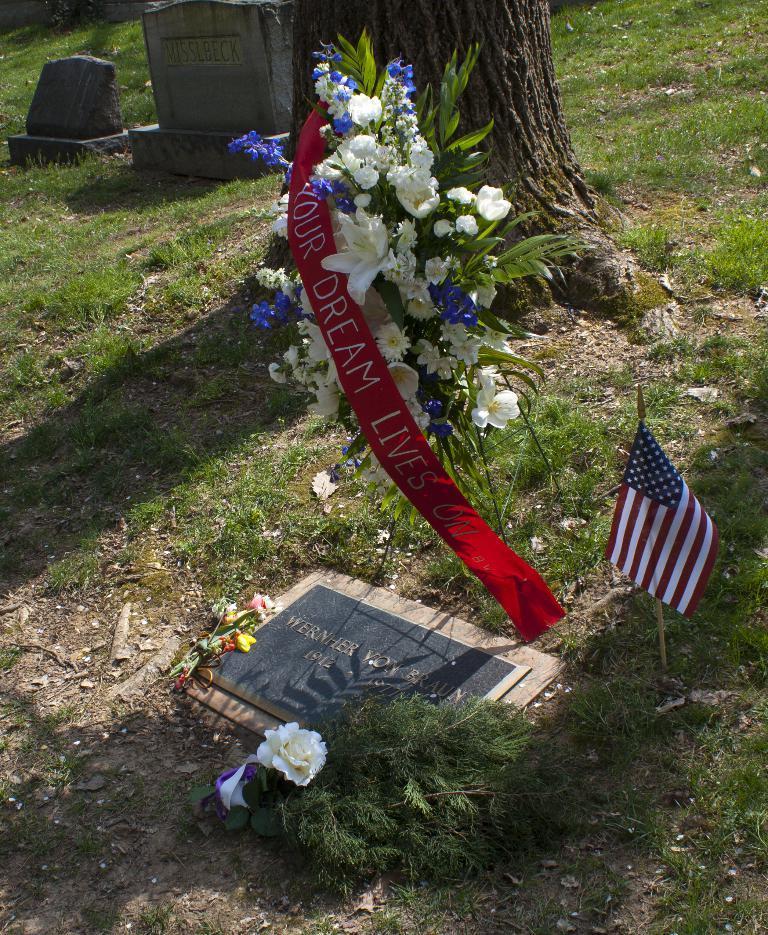Please provide a concise description of this image. In this image there is a gravestone on that there is text beside the stone there is a bookey , flag and flowers and a badge, in the background there is grassland, tree, and stones. 